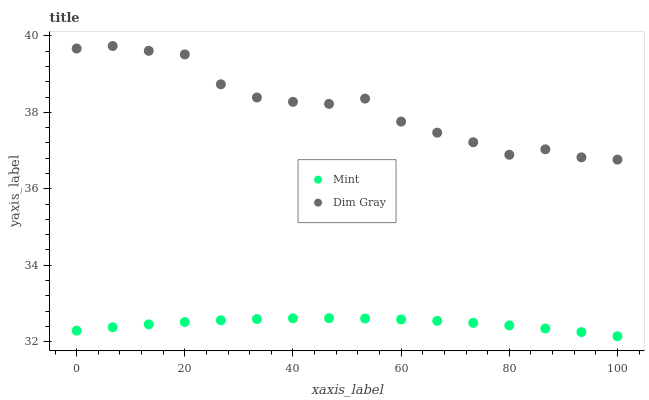Does Mint have the minimum area under the curve?
Answer yes or no. Yes. Does Dim Gray have the maximum area under the curve?
Answer yes or no. Yes. Does Mint have the maximum area under the curve?
Answer yes or no. No. Is Mint the smoothest?
Answer yes or no. Yes. Is Dim Gray the roughest?
Answer yes or no. Yes. Is Mint the roughest?
Answer yes or no. No. Does Mint have the lowest value?
Answer yes or no. Yes. Does Dim Gray have the highest value?
Answer yes or no. Yes. Does Mint have the highest value?
Answer yes or no. No. Is Mint less than Dim Gray?
Answer yes or no. Yes. Is Dim Gray greater than Mint?
Answer yes or no. Yes. Does Mint intersect Dim Gray?
Answer yes or no. No. 